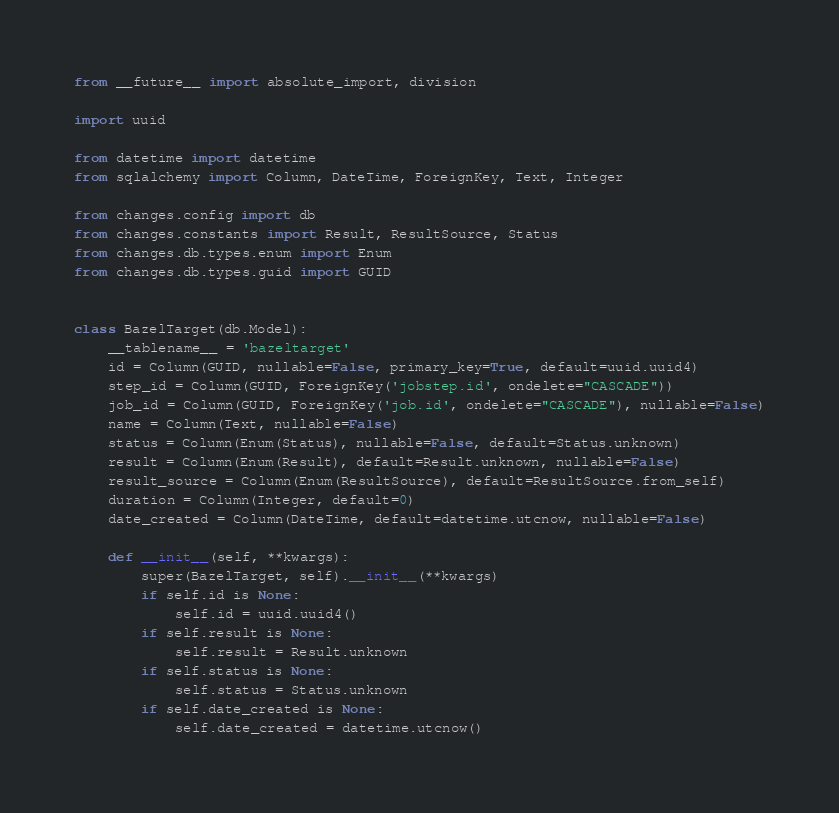Convert code to text. <code><loc_0><loc_0><loc_500><loc_500><_Python_>from __future__ import absolute_import, division

import uuid

from datetime import datetime
from sqlalchemy import Column, DateTime, ForeignKey, Text, Integer

from changes.config import db
from changes.constants import Result, ResultSource, Status
from changes.db.types.enum import Enum
from changes.db.types.guid import GUID


class BazelTarget(db.Model):
    __tablename__ = 'bazeltarget'
    id = Column(GUID, nullable=False, primary_key=True, default=uuid.uuid4)
    step_id = Column(GUID, ForeignKey('jobstep.id', ondelete="CASCADE"))
    job_id = Column(GUID, ForeignKey('job.id', ondelete="CASCADE"), nullable=False)
    name = Column(Text, nullable=False)
    status = Column(Enum(Status), nullable=False, default=Status.unknown)
    result = Column(Enum(Result), default=Result.unknown, nullable=False)
    result_source = Column(Enum(ResultSource), default=ResultSource.from_self)
    duration = Column(Integer, default=0)
    date_created = Column(DateTime, default=datetime.utcnow, nullable=False)

    def __init__(self, **kwargs):
        super(BazelTarget, self).__init__(**kwargs)
        if self.id is None:
            self.id = uuid.uuid4()
        if self.result is None:
            self.result = Result.unknown
        if self.status is None:
            self.status = Status.unknown
        if self.date_created is None:
            self.date_created = datetime.utcnow()
</code> 